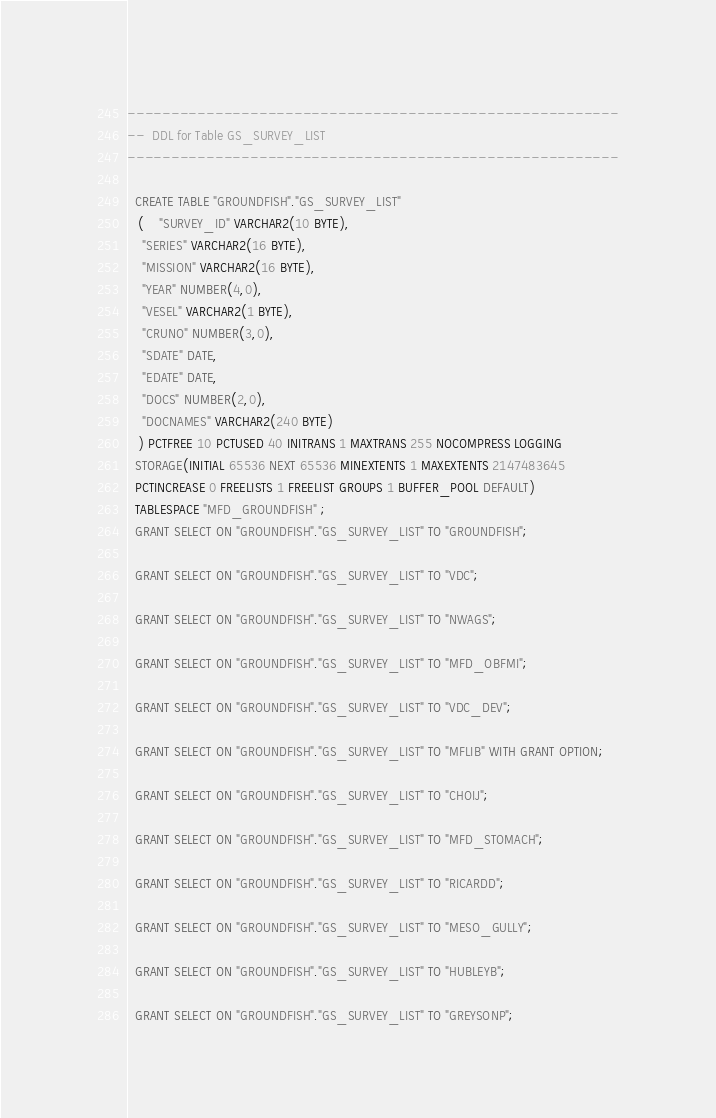<code> <loc_0><loc_0><loc_500><loc_500><_SQL_>--------------------------------------------------------
--  DDL for Table GS_SURVEY_LIST
--------------------------------------------------------

  CREATE TABLE "GROUNDFISH"."GS_SURVEY_LIST" 
   (	"SURVEY_ID" VARCHAR2(10 BYTE), 
	"SERIES" VARCHAR2(16 BYTE), 
	"MISSION" VARCHAR2(16 BYTE), 
	"YEAR" NUMBER(4,0), 
	"VESEL" VARCHAR2(1 BYTE), 
	"CRUNO" NUMBER(3,0), 
	"SDATE" DATE, 
	"EDATE" DATE, 
	"DOCS" NUMBER(2,0), 
	"DOCNAMES" VARCHAR2(240 BYTE)
   ) PCTFREE 10 PCTUSED 40 INITRANS 1 MAXTRANS 255 NOCOMPRESS LOGGING
  STORAGE(INITIAL 65536 NEXT 65536 MINEXTENTS 1 MAXEXTENTS 2147483645
  PCTINCREASE 0 FREELISTS 1 FREELIST GROUPS 1 BUFFER_POOL DEFAULT)
  TABLESPACE "MFD_GROUNDFISH" ;
  GRANT SELECT ON "GROUNDFISH"."GS_SURVEY_LIST" TO "GROUNDFISH";
 
  GRANT SELECT ON "GROUNDFISH"."GS_SURVEY_LIST" TO "VDC";
 
  GRANT SELECT ON "GROUNDFISH"."GS_SURVEY_LIST" TO "NWAGS";
 
  GRANT SELECT ON "GROUNDFISH"."GS_SURVEY_LIST" TO "MFD_OBFMI";
 
  GRANT SELECT ON "GROUNDFISH"."GS_SURVEY_LIST" TO "VDC_DEV";
 
  GRANT SELECT ON "GROUNDFISH"."GS_SURVEY_LIST" TO "MFLIB" WITH GRANT OPTION;
 
  GRANT SELECT ON "GROUNDFISH"."GS_SURVEY_LIST" TO "CHOIJ";
 
  GRANT SELECT ON "GROUNDFISH"."GS_SURVEY_LIST" TO "MFD_STOMACH";
 
  GRANT SELECT ON "GROUNDFISH"."GS_SURVEY_LIST" TO "RICARDD";
 
  GRANT SELECT ON "GROUNDFISH"."GS_SURVEY_LIST" TO "MESO_GULLY";
 
  GRANT SELECT ON "GROUNDFISH"."GS_SURVEY_LIST" TO "HUBLEYB";
 
  GRANT SELECT ON "GROUNDFISH"."GS_SURVEY_LIST" TO "GREYSONP";
</code> 